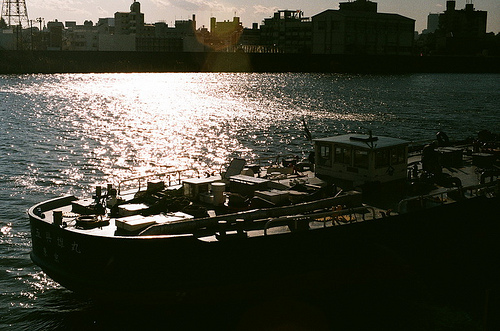Which side of the photo is the man on, the left or the right? The image does not include any individuals, thus the question about the man's position doesn’t apply here. 